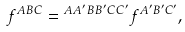<formula> <loc_0><loc_0><loc_500><loc_500>f ^ { A B C } = \L ^ { A A ^ { \prime } } \L ^ { B B ^ { \prime } } \L ^ { C C ^ { \prime } } f ^ { A ^ { \prime } B ^ { \prime } C ^ { \prime } } ,</formula> 